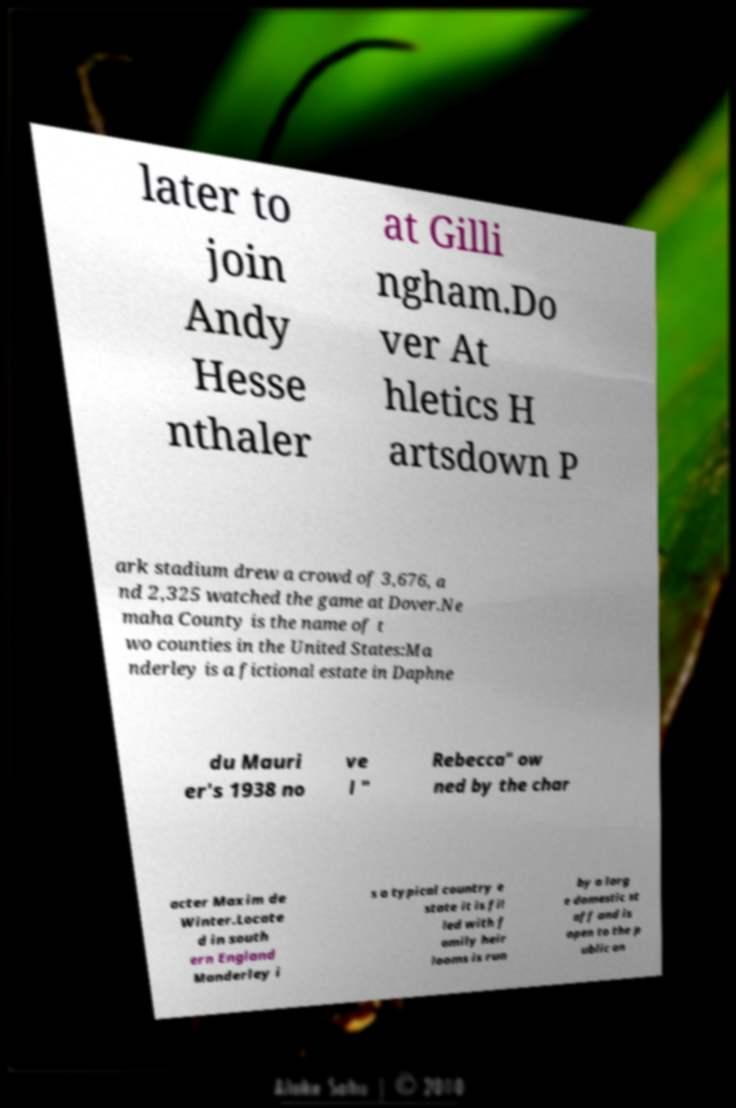Can you accurately transcribe the text from the provided image for me? later to join Andy Hesse nthaler at Gilli ngham.Do ver At hletics H artsdown P ark stadium drew a crowd of 3,676, a nd 2,325 watched the game at Dover.Ne maha County is the name of t wo counties in the United States:Ma nderley is a fictional estate in Daphne du Mauri er's 1938 no ve l " Rebecca" ow ned by the char acter Maxim de Winter.Locate d in south ern England Manderley i s a typical country e state it is fil led with f amily heir looms is run by a larg e domestic st aff and is open to the p ublic on 